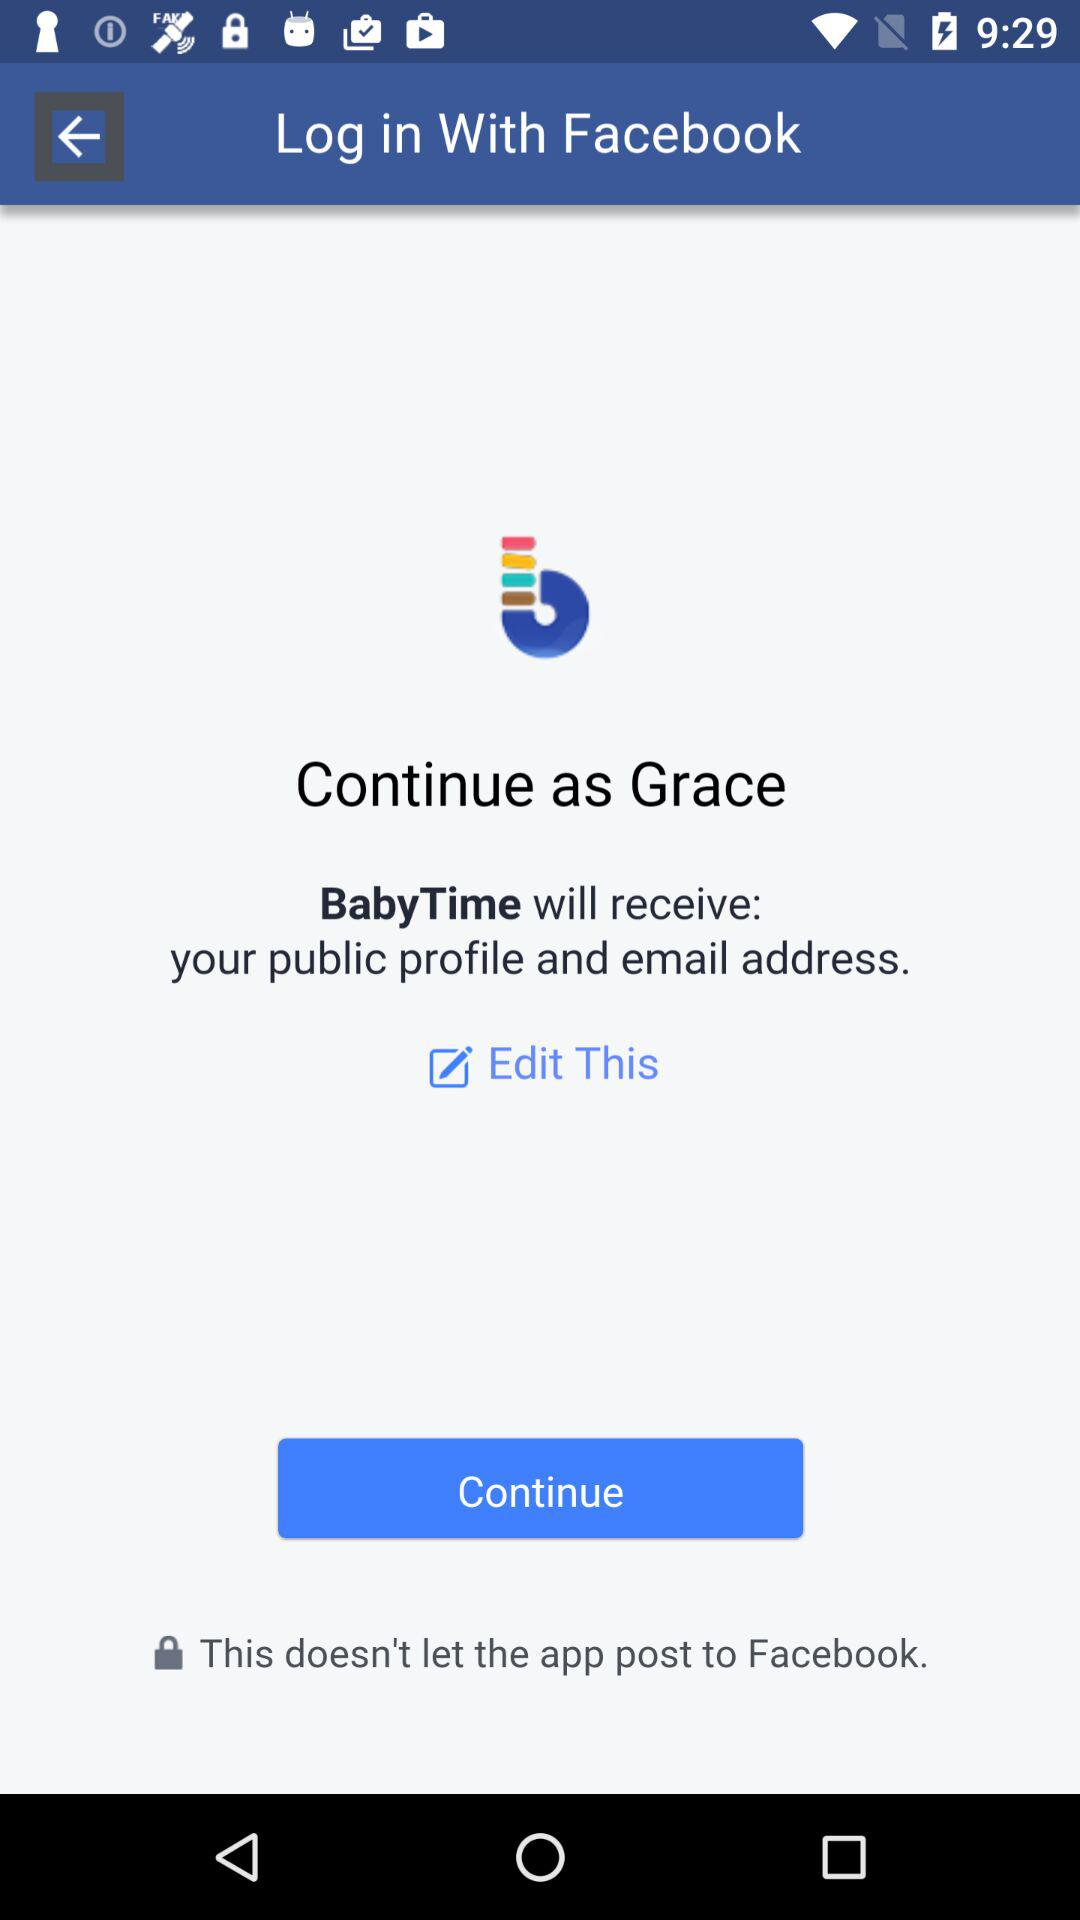What is the login name? The login name is Grace. 